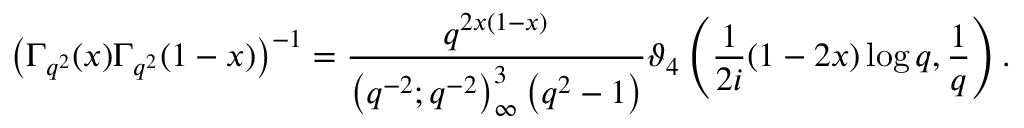Convert formula to latex. <formula><loc_0><loc_0><loc_500><loc_500>\left ( \Gamma _ { q ^ { 2 } } ( x ) \Gamma _ { q ^ { 2 } } ( 1 - x ) \right ) ^ { - 1 } = { \frac { q ^ { 2 x ( 1 - x ) } } { \left ( q ^ { - 2 } ; q ^ { - 2 } \right ) _ { \infty } ^ { 3 } \left ( q ^ { 2 } - 1 \right ) } } \vartheta _ { 4 } \left ( { \frac { 1 } { 2 i } } ( 1 - 2 x ) \log q , { \frac { 1 } { q } } \right ) .</formula> 